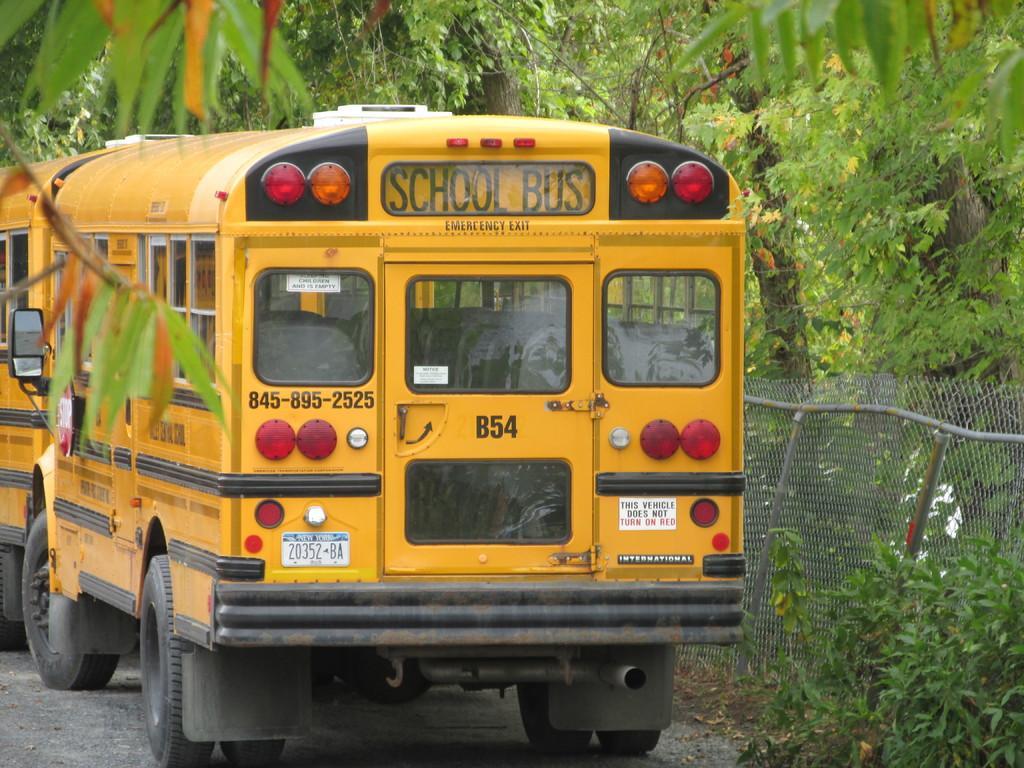Could you give a brief overview of what you see in this image? There are yellow color buses with light, windows and something is written on that. On the right side there is a fencing. Also there are trees. 